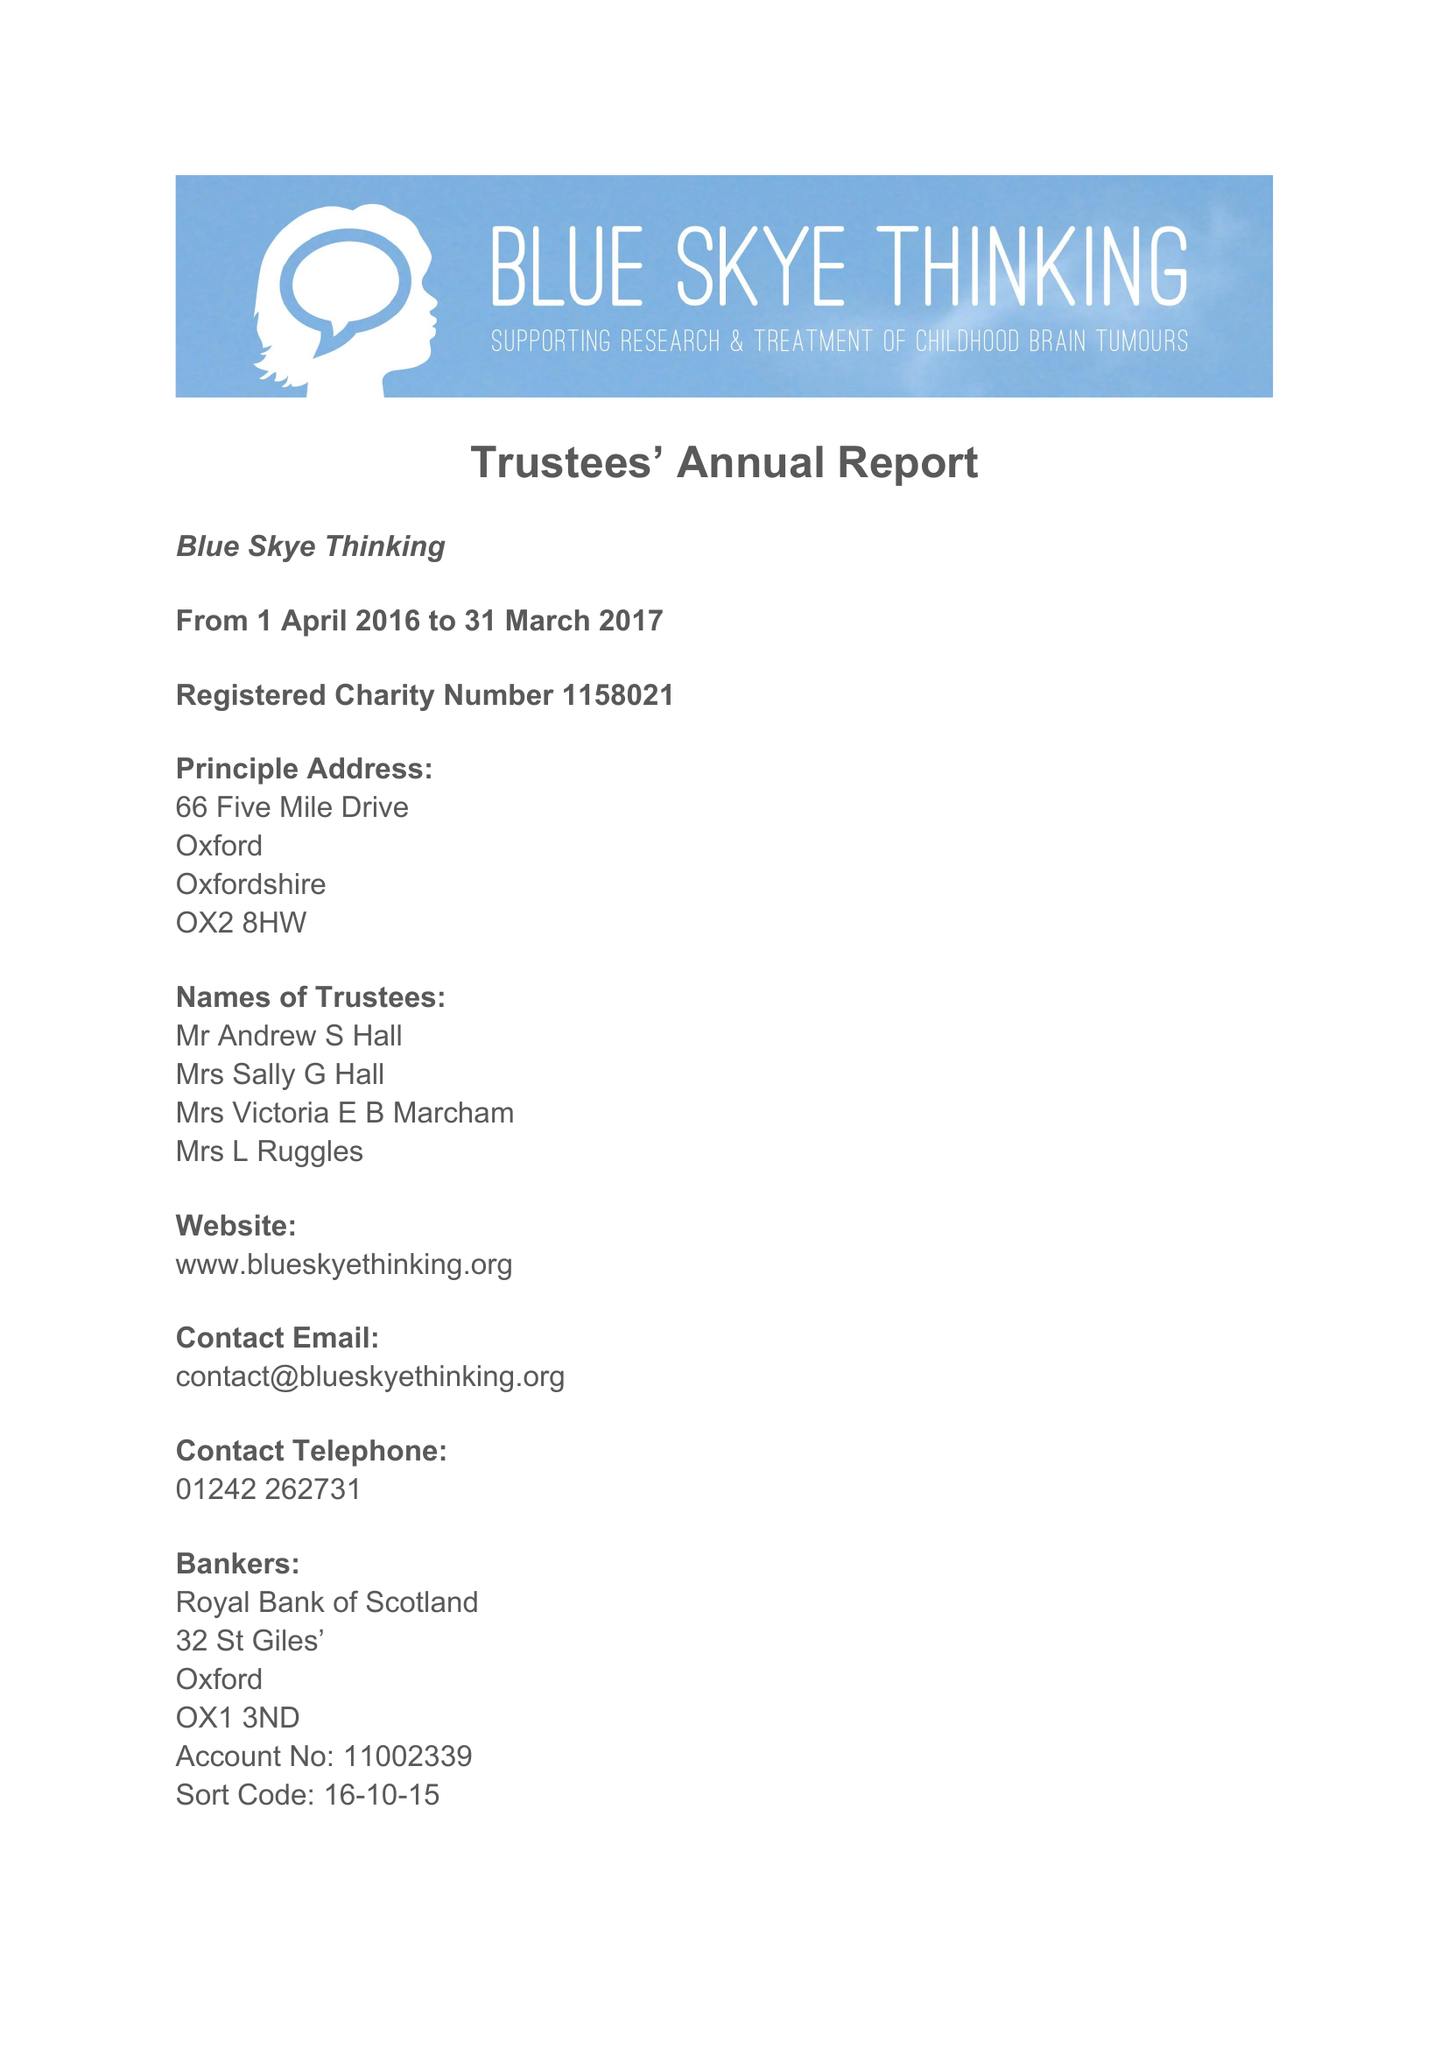What is the value for the report_date?
Answer the question using a single word or phrase. 2017-03-31 